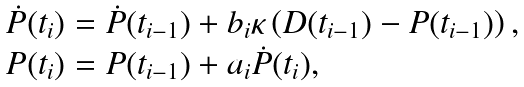Convert formula to latex. <formula><loc_0><loc_0><loc_500><loc_500>\begin{array} { l } { \dot { P } } ( t _ { i } ) = { \dot { P } } ( t _ { i - 1 } ) + b _ { i } \kappa \left ( D ( t _ { i - 1 } ) - P ( t _ { i - 1 } ) \right ) , \\ P ( t _ { i } ) = P ( t _ { i - 1 } ) + a _ { i } { \dot { P } } ( t _ { i } ) , \end{array}</formula> 